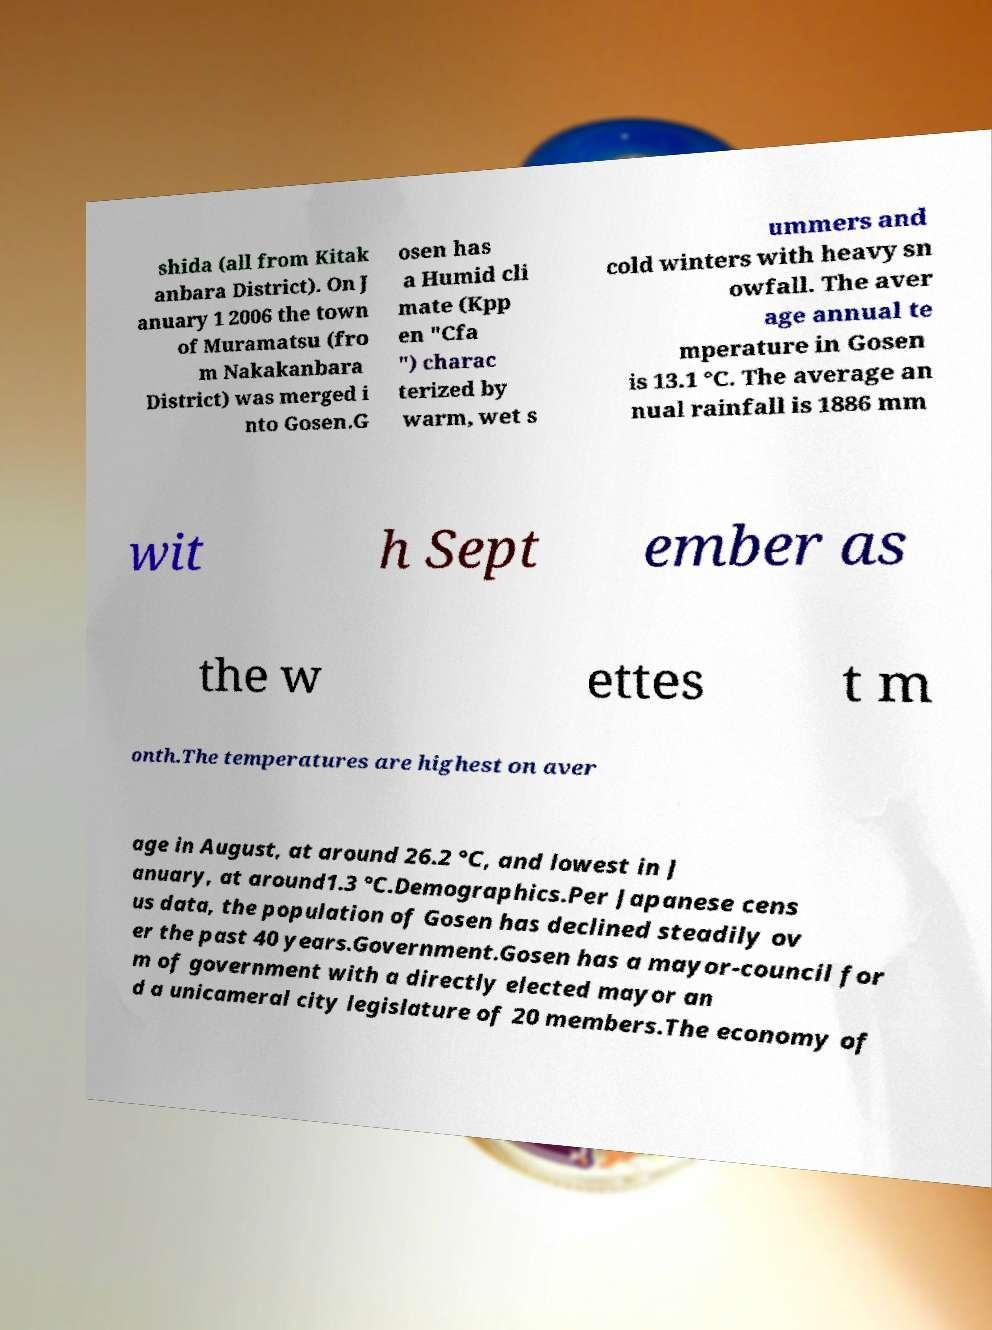Can you read and provide the text displayed in the image?This photo seems to have some interesting text. Can you extract and type it out for me? shida (all from Kitak anbara District). On J anuary 1 2006 the town of Muramatsu (fro m Nakakanbara District) was merged i nto Gosen.G osen has a Humid cli mate (Kpp en "Cfa ") charac terized by warm, wet s ummers and cold winters with heavy sn owfall. The aver age annual te mperature in Gosen is 13.1 °C. The average an nual rainfall is 1886 mm wit h Sept ember as the w ettes t m onth.The temperatures are highest on aver age in August, at around 26.2 °C, and lowest in J anuary, at around1.3 °C.Demographics.Per Japanese cens us data, the population of Gosen has declined steadily ov er the past 40 years.Government.Gosen has a mayor-council for m of government with a directly elected mayor an d a unicameral city legislature of 20 members.The economy of 